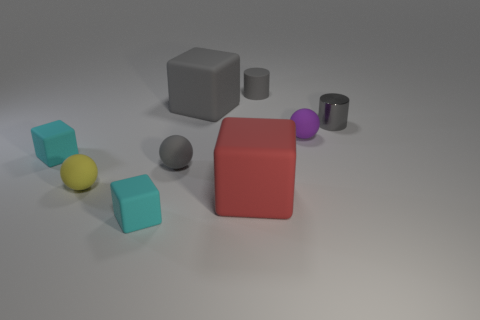There is a rubber cylinder that is the same size as the shiny object; what is its color?
Offer a very short reply. Gray. How many tiny objects are either rubber blocks or rubber objects?
Offer a terse response. 6. Are there the same number of rubber things in front of the yellow thing and small cyan matte blocks to the right of the small gray matte cylinder?
Make the answer very short. No. What number of metal objects are the same size as the gray shiny cylinder?
Your response must be concise. 0. What number of red objects are big blocks or blocks?
Offer a terse response. 1. Are there an equal number of tiny cyan rubber cubes that are behind the large gray matte object and rubber cylinders?
Give a very brief answer. No. What size is the gray cylinder behind the shiny cylinder?
Keep it short and to the point. Small. How many other small things are the same shape as the metal thing?
Your answer should be very brief. 1. There is a small gray object that is both right of the red matte object and in front of the gray rubber block; what material is it made of?
Your answer should be very brief. Metal. Is the material of the red thing the same as the gray sphere?
Your answer should be compact. Yes. 